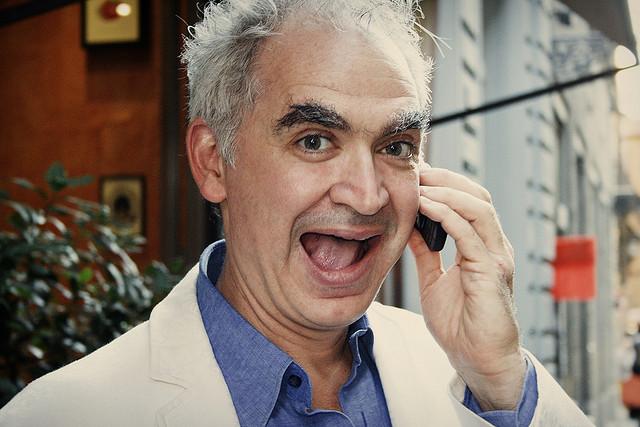Is he wearing glasses?
Short answer required. No. How many people are aware that they are being photographed in this image?
Be succinct. 1. What color are the man's eyes?
Quick response, please. Brown. Who is he talking to?
Concise answer only. Wife. Is this gentlemen crying?
Give a very brief answer. No. What is his expression?
Write a very short answer. Surprise. Has this person recently had an eyebrow waxing?
Answer briefly. No. Is he alone?
Be succinct. Yes. Is the man most likely a college student or choir director?
Keep it brief. Choir director. Is he sticking his tongue out?
Be succinct. No. What is the man holding?
Write a very short answer. Phone. Is his top button open?
Be succinct. Yes. 